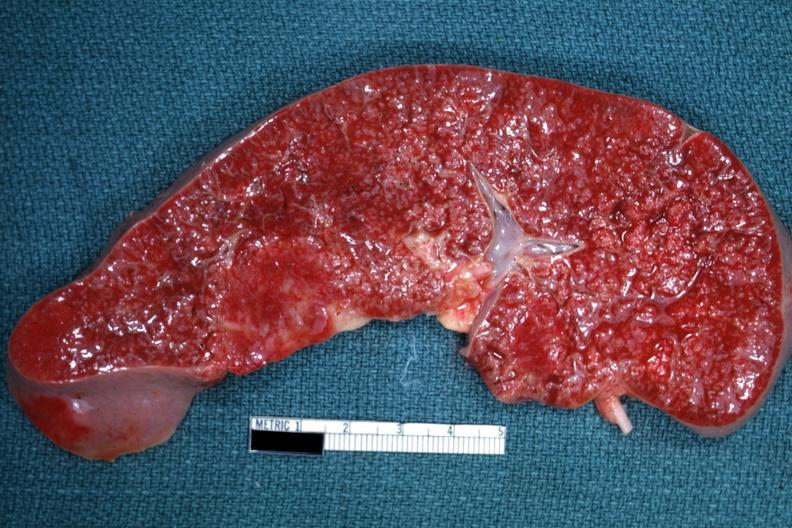what is cut surface with multiple small infiltrates that simulate granulomata diagnosed?
Answer the question using a single word or phrase. As reticulum cell sarcoma 